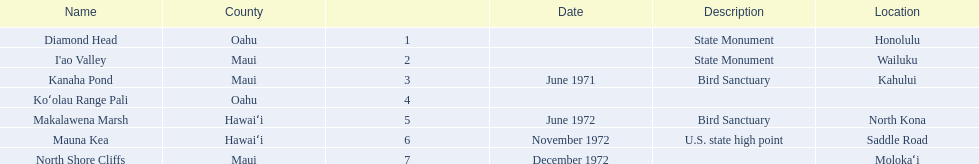What is the only name listed without a location? Koʻolau Range Pali. 